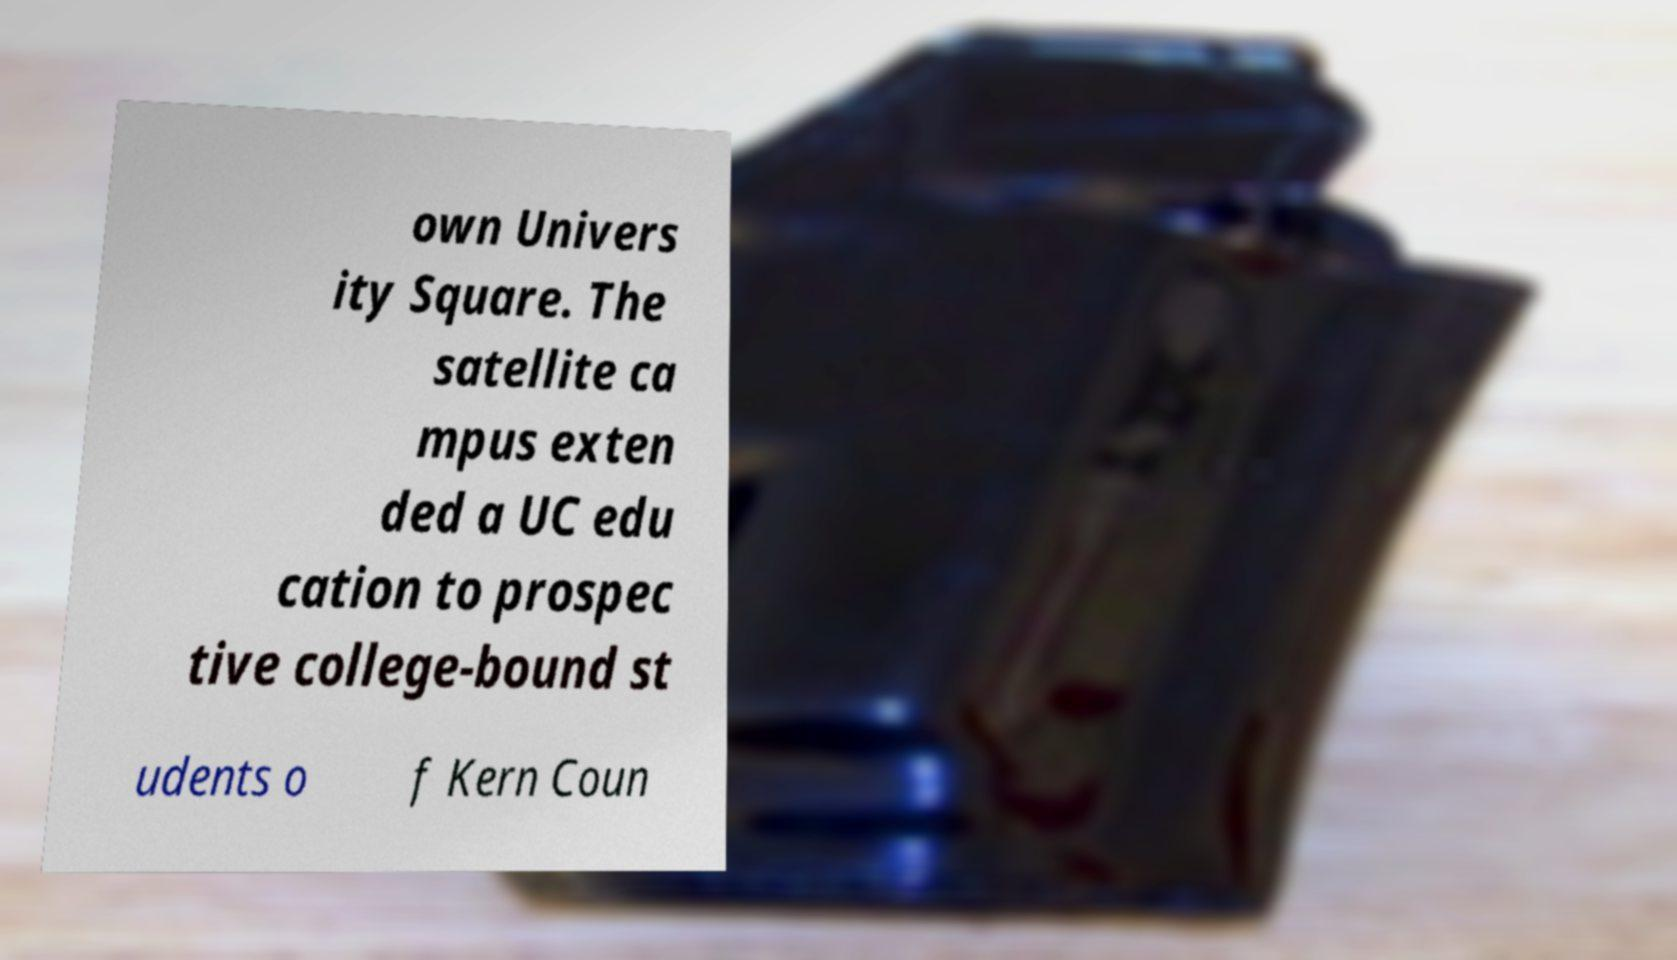Could you extract and type out the text from this image? own Univers ity Square. The satellite ca mpus exten ded a UC edu cation to prospec tive college-bound st udents o f Kern Coun 